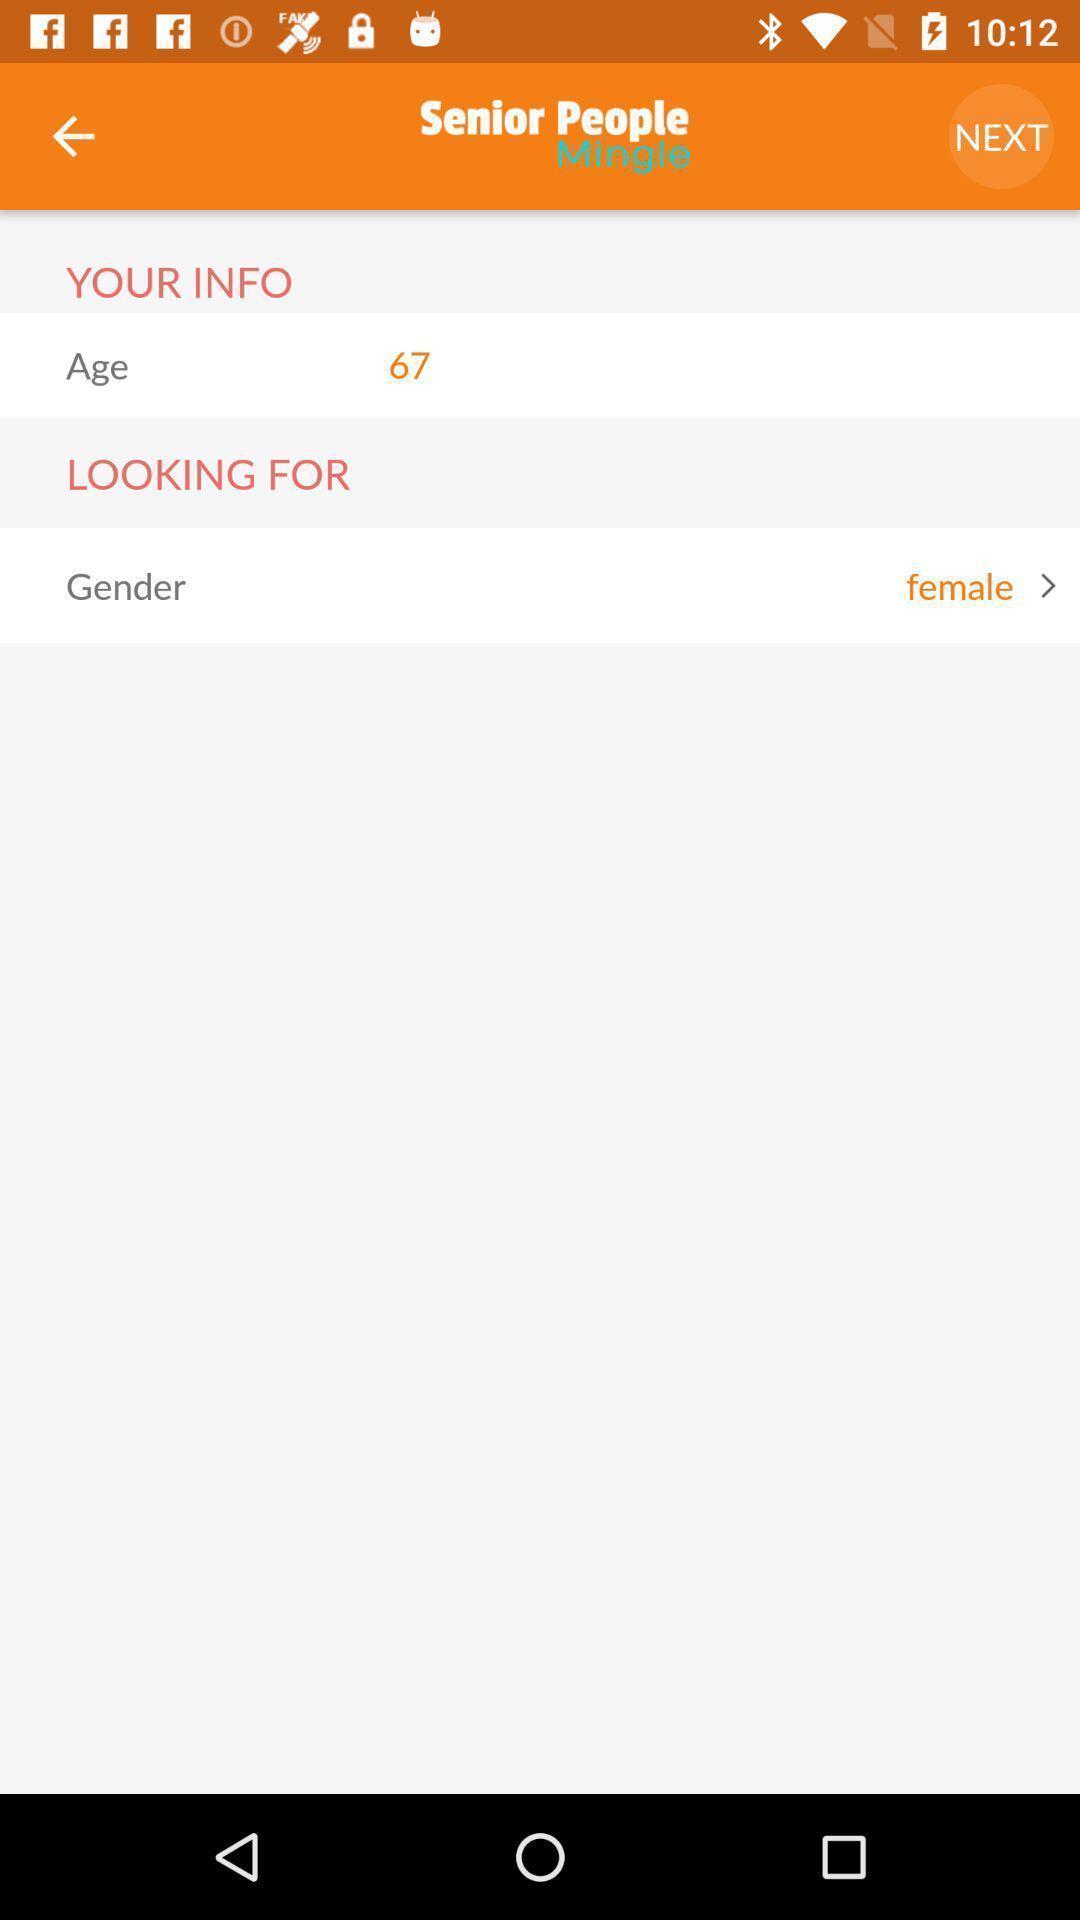Provide a description of this screenshot. Search page. 